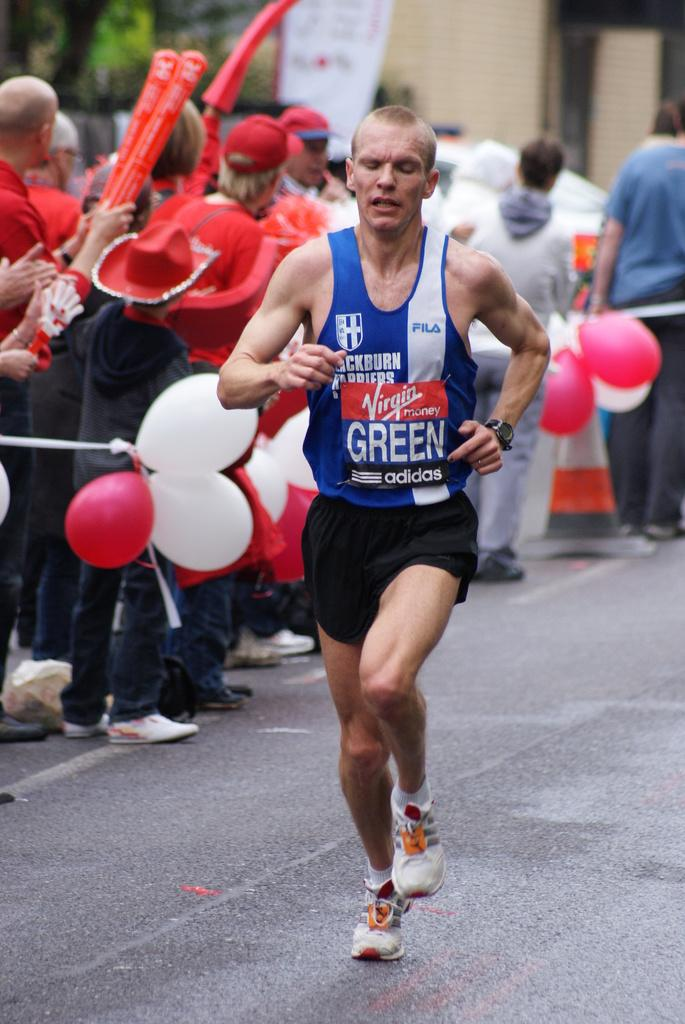Provide a one-sentence caption for the provided image. A marathon player run in the track whose jersey has lettering as Virgin money ,green ,adidas. 